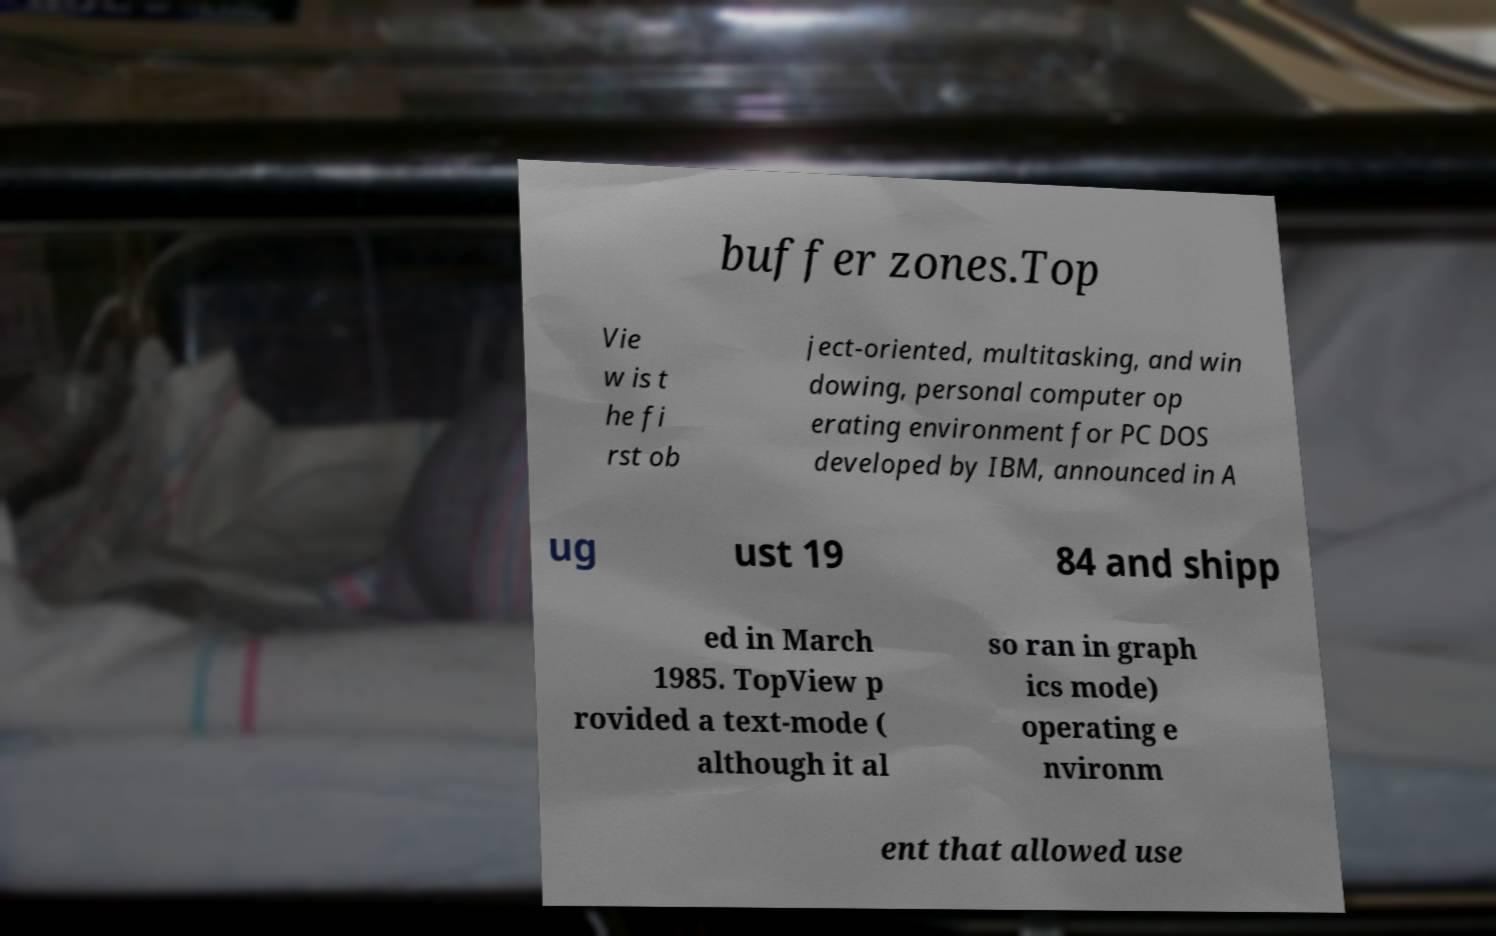What messages or text are displayed in this image? I need them in a readable, typed format. buffer zones.Top Vie w is t he fi rst ob ject-oriented, multitasking, and win dowing, personal computer op erating environment for PC DOS developed by IBM, announced in A ug ust 19 84 and shipp ed in March 1985. TopView p rovided a text-mode ( although it al so ran in graph ics mode) operating e nvironm ent that allowed use 